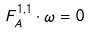<formula> <loc_0><loc_0><loc_500><loc_500>F _ { A } ^ { 1 , 1 } \cdot \omega = 0</formula> 